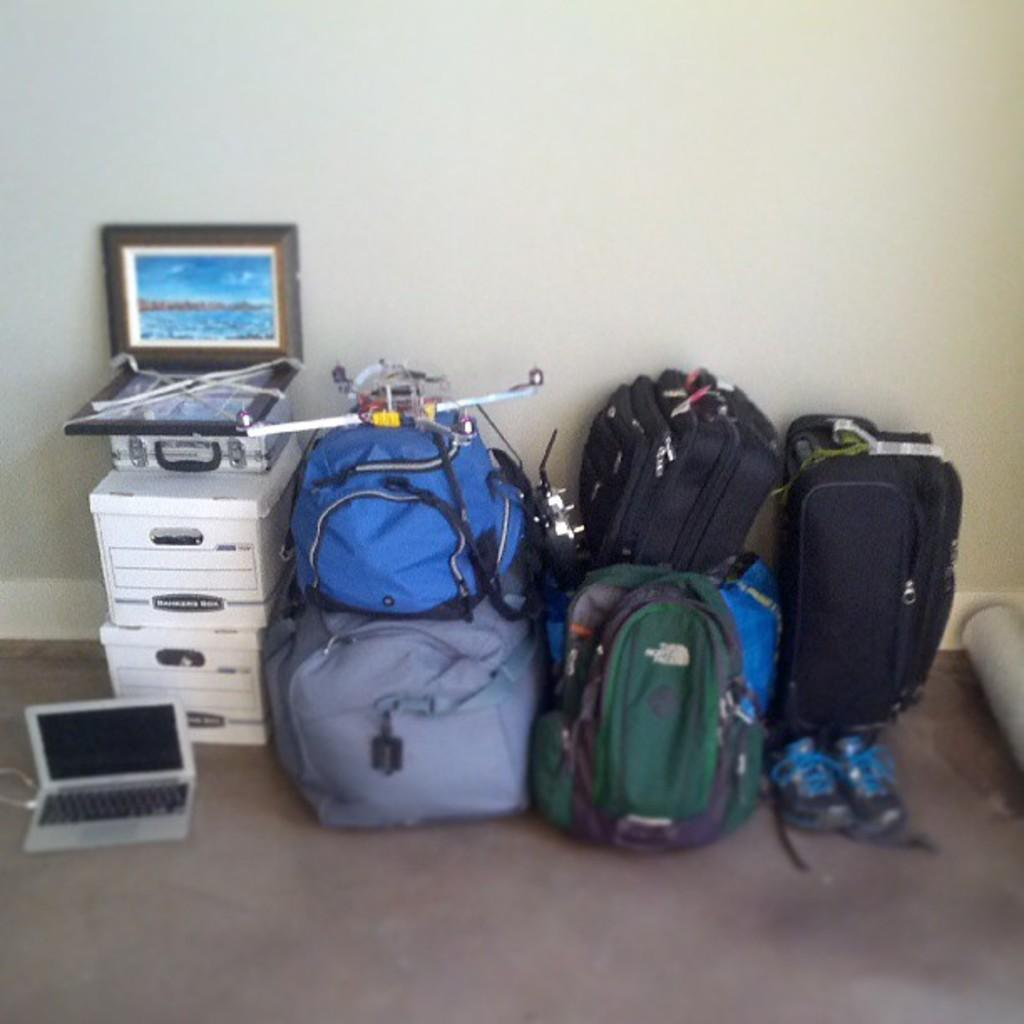What is the setting of the image? The image is inside a room. What electronic device can be seen in the image? There is a laptop in the image. What type of items are present in the image that might be used for carrying or storing things? There are bags in the image. What type of decorative item is present in the image? There is a photo frame in the image. What type of footwear is present in the image? There are shoes in the image. What type of sock is visible on the hand in the image? There is no sock or hand visible in the image. 